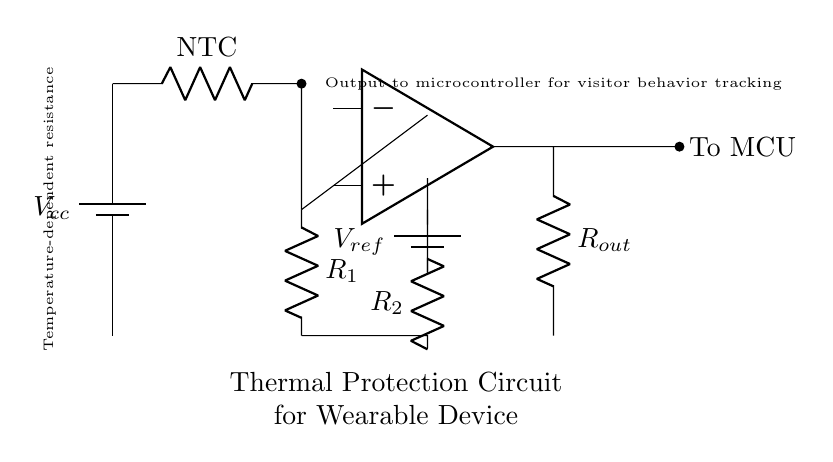What is the function of the thermistor in this circuit? The thermistor is a temperature-dependent resistor that changes its resistance based on temperature. In this circuit, it likely acts as a sensor to monitor the temperature of the wearable device.
Answer: Temperature sensor What component provides the reference voltage? The reference voltage is provided by the battery labeled as V_ref, which connects to a resistor (R2) to establish a stable voltage for comparison.
Answer: Battery Which component connects to the microcontroller? The output connected to the microcontroller (labeled as "To MCU") comes from the output of the comparator after processing the signals.
Answer: Comparator output What type of resistor is labeled NTC? The NTC resistor is a Negative Temperature Coefficient thermistor, which decreases resistance as temperature rises, enabling temperature monitoring.
Answer: Negative Temperature Coefficient What does the output resistor (R_out) do? The output resistor is likely involved in interfacing the comparator output to the microcontroller, possibly limiting the current or voltage for safe operation.
Answer: Current limiting Why is the voltage divider created in this circuit? The voltage divider is created using resistors to scale down the voltage from the thermistor and provide a corresponding input level for the comparator that can be compared against the reference.
Answer: To scale voltage 